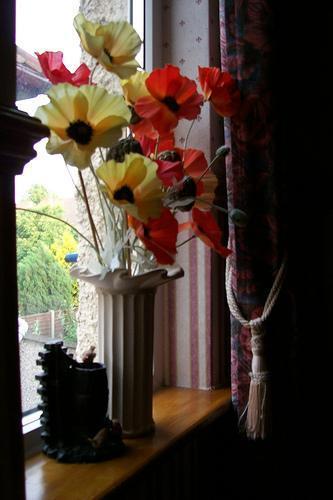How many vases are there?
Give a very brief answer. 1. 